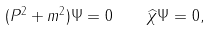<formula> <loc_0><loc_0><loc_500><loc_500>( P ^ { 2 } + m ^ { 2 } ) \Psi = 0 \quad \widehat { \chi } \Psi = 0 ,</formula> 